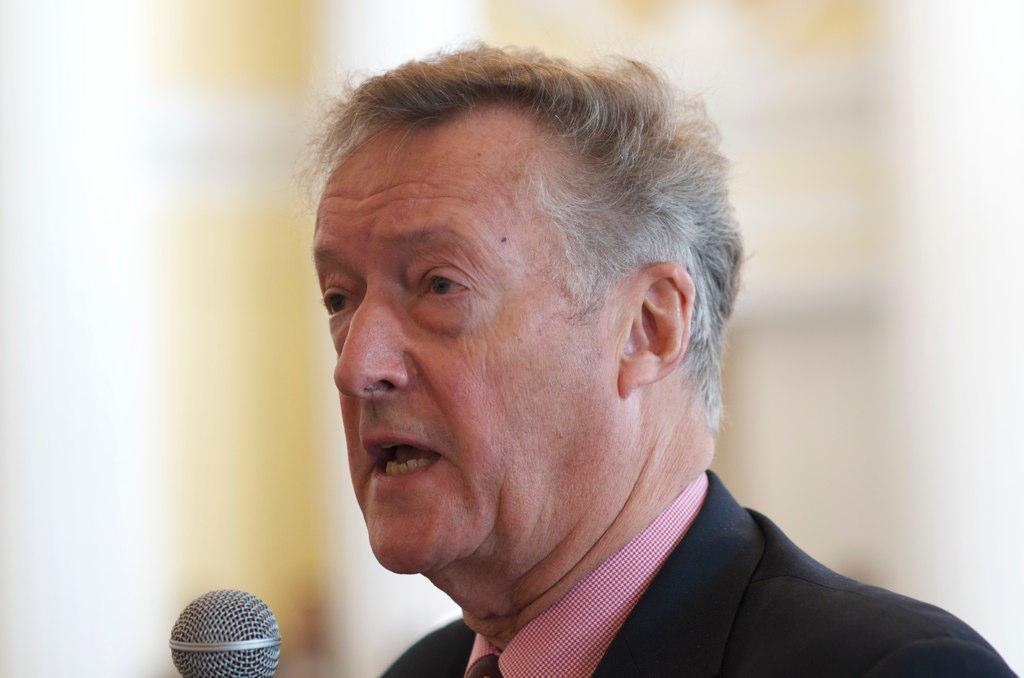What is the main subject of the image? There is a person in the image. What is the person doing in the image? The person is speaking in the image. What object is the person using while speaking? The person is in front of a microphone. Can you describe the background of the image? The background of the image is blurry. What type of education can be seen in the image? There is no indication of education in the image; it features a person speaking in front of a microphone with a blurry background. What color is the gold object in the image? There is no gold object present in the image. 